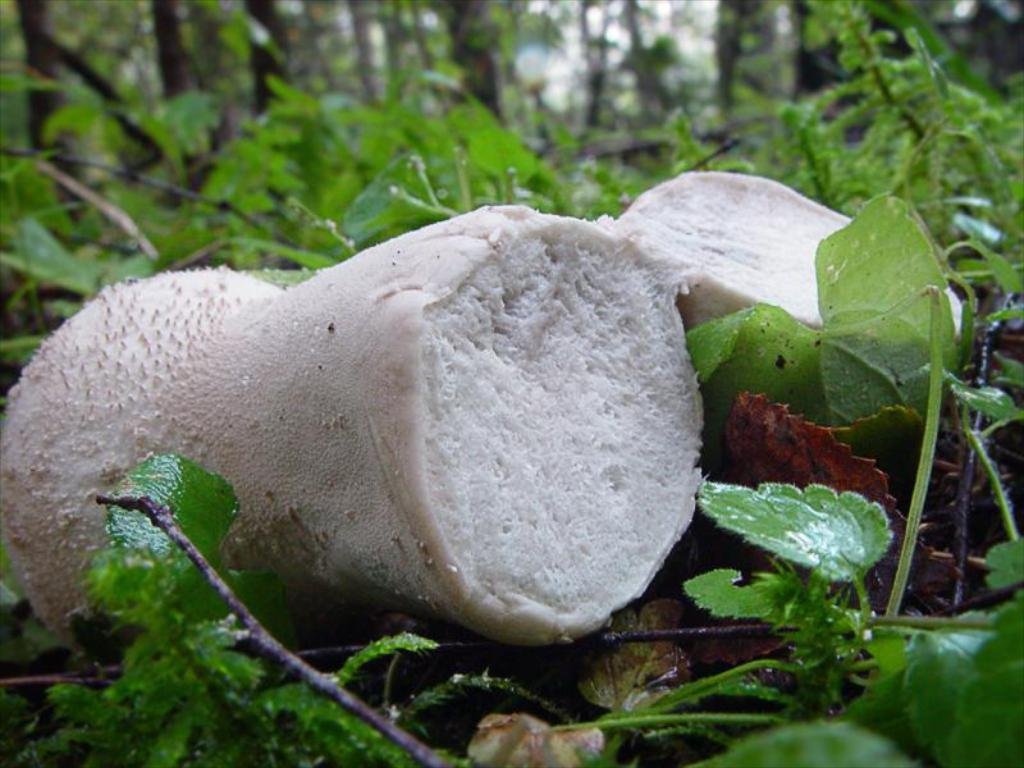What type of vegetation is in the front of the image? There are leaves in the front of the image. What is the main subject in the center of the image? There is a mushroom in the center of the image. What color is the mushroom? The mushroom is white in color. What can be seen in the background of the image? There are trees in the background of the image. How many properties does the mushroom own in the image? The mushroom does not own any properties in the image, as it is an inanimate object. Can you see the aunt's toes in the image? There is no mention of an aunt or toes in the image, so it cannot be determined if they are present. 